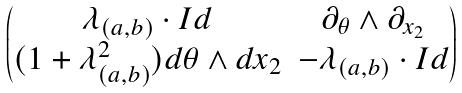<formula> <loc_0><loc_0><loc_500><loc_500>\begin{pmatrix} \lambda _ { ( a , b ) } \cdot I d & \partial _ { \theta } \wedge \partial _ { x _ { 2 } } \\ ( 1 + \lambda _ { ( a , b ) } ^ { 2 } ) d \theta \wedge d x _ { 2 } & - \lambda _ { ( a , b ) } \cdot I d \end{pmatrix}</formula> 